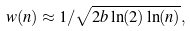<formula> <loc_0><loc_0><loc_500><loc_500>w ( n ) \approx 1 / { \sqrt { 2 b \ln ( 2 ) \ln ( n ) } } ,</formula> 